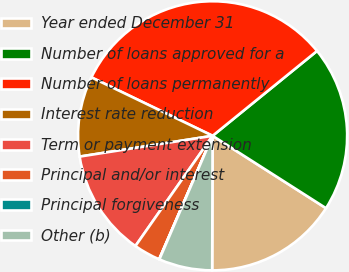Convert chart. <chart><loc_0><loc_0><loc_500><loc_500><pie_chart><fcel>Year ended December 31<fcel>Number of loans approved for a<fcel>Number of loans permanently<fcel>Interest rate reduction<fcel>Term or payment extension<fcel>Principal and/or interest<fcel>Principal forgiveness<fcel>Other (b)<nl><fcel>16.01%<fcel>19.9%<fcel>31.99%<fcel>9.62%<fcel>12.81%<fcel>3.22%<fcel>0.03%<fcel>6.42%<nl></chart> 